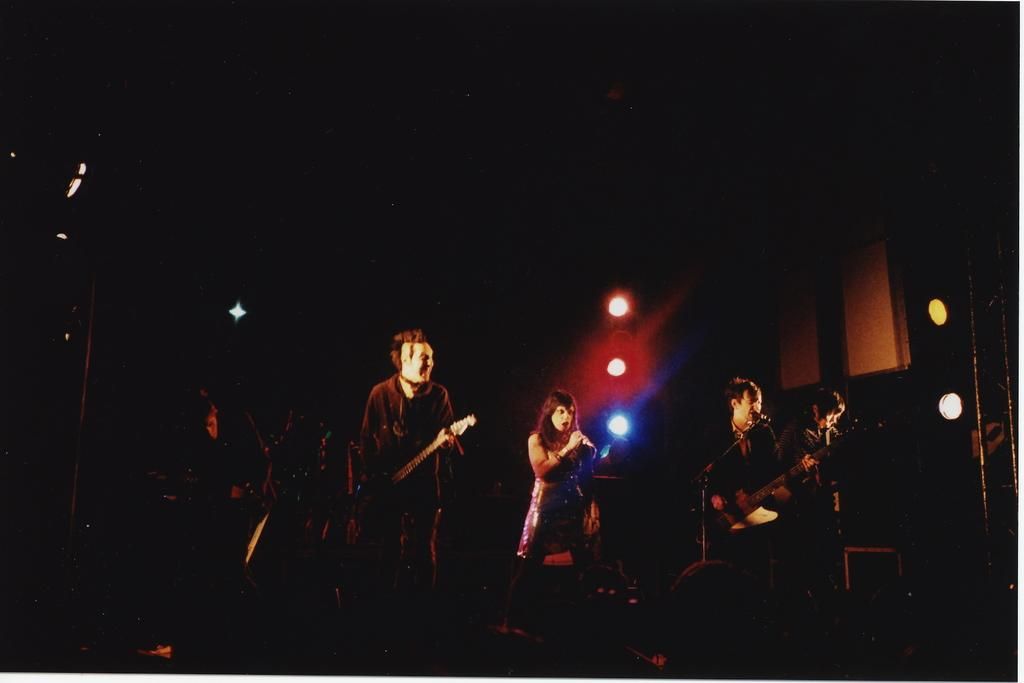How many people are in the image? There are people in the image, but the exact number is not specified. What are the people doing in the image? The people are standing and playing musical instruments. What equipment is set up in front of the people? There are microphones in front of the people. What is located behind the people? There are lights behind the people. What can be inferred about the lighting conditions in the image? The background of the image is dark, which suggests that the lighting may be dim or focused on the people and their instruments. Can you see any snails crawling on the musical instruments in the image? There is no mention of snails or any other animals in the image, so it is not possible to answer this question. 